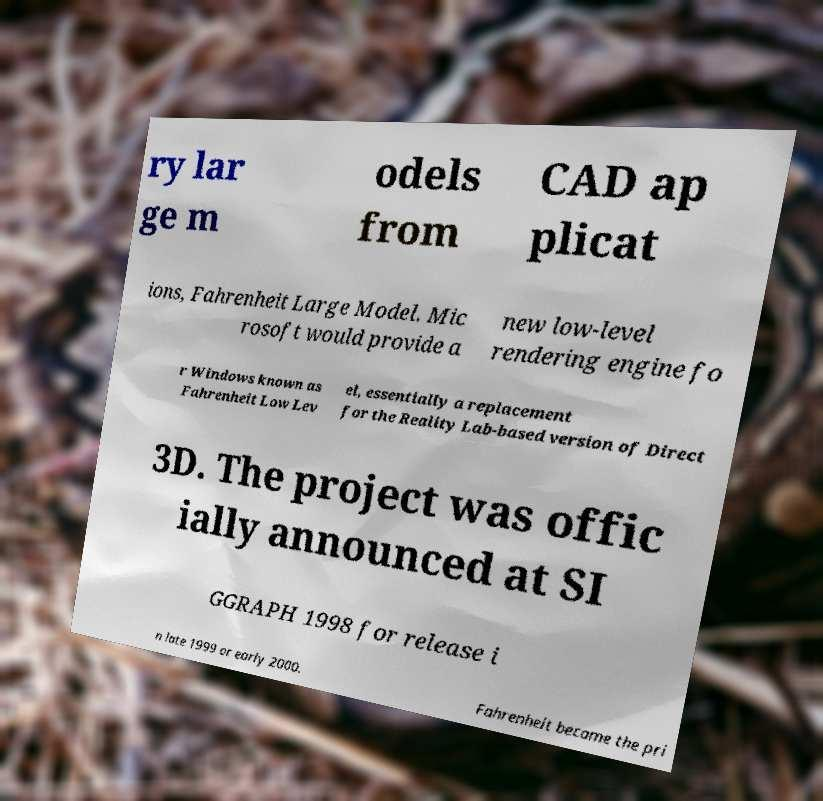For documentation purposes, I need the text within this image transcribed. Could you provide that? ry lar ge m odels from CAD ap plicat ions, Fahrenheit Large Model. Mic rosoft would provide a new low-level rendering engine fo r Windows known as Fahrenheit Low Lev el, essentially a replacement for the Reality Lab-based version of Direct 3D. The project was offic ially announced at SI GGRAPH 1998 for release i n late 1999 or early 2000. Fahrenheit became the pri 